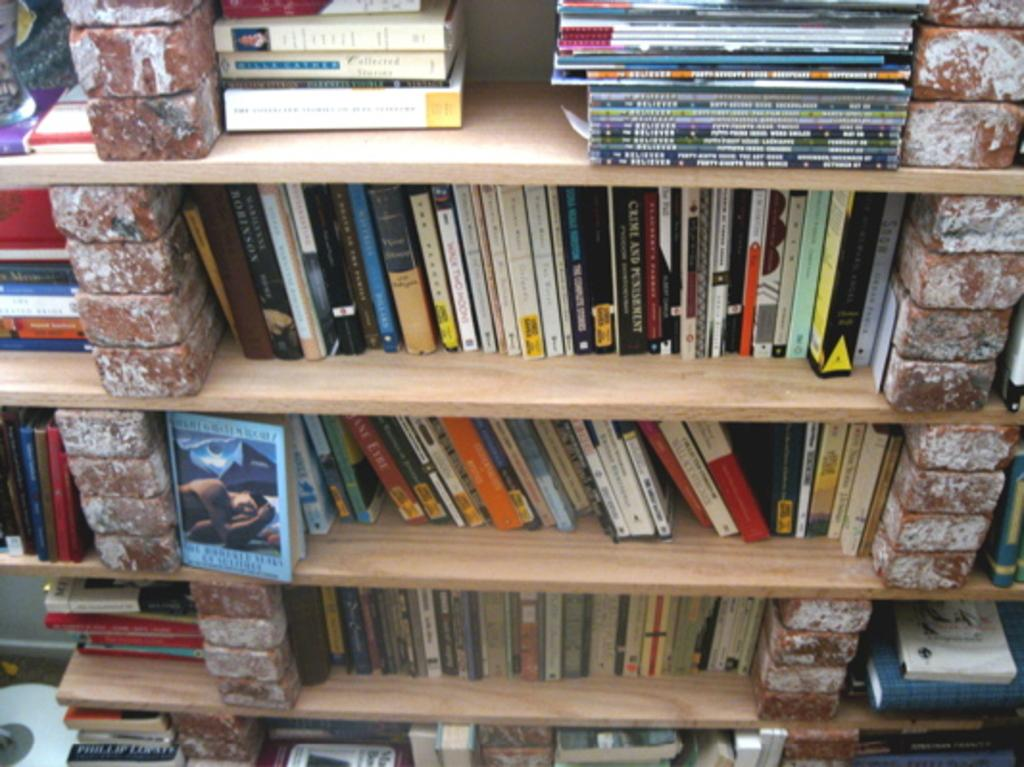What type of material is used for the surfaces in the image? There are wooden surfaces in the image. What can be seen on top of the wooden surfaces? There are books on the wooden surfaces. Are there any visible imperfections on the wooden surfaces? Yes, there are cracks on the wooden surfaces. Can you see any toys on the wooden surfaces in the image? No, there are no toys visible on the wooden surfaces in the image. 